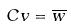Convert formula to latex. <formula><loc_0><loc_0><loc_500><loc_500>C v = \overline { w }</formula> 